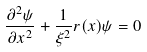<formula> <loc_0><loc_0><loc_500><loc_500>\frac { \partial ^ { 2 } \psi } { \partial { x } ^ { 2 } } + \frac { 1 } { \xi ^ { 2 } } r ( x ) \psi = 0</formula> 